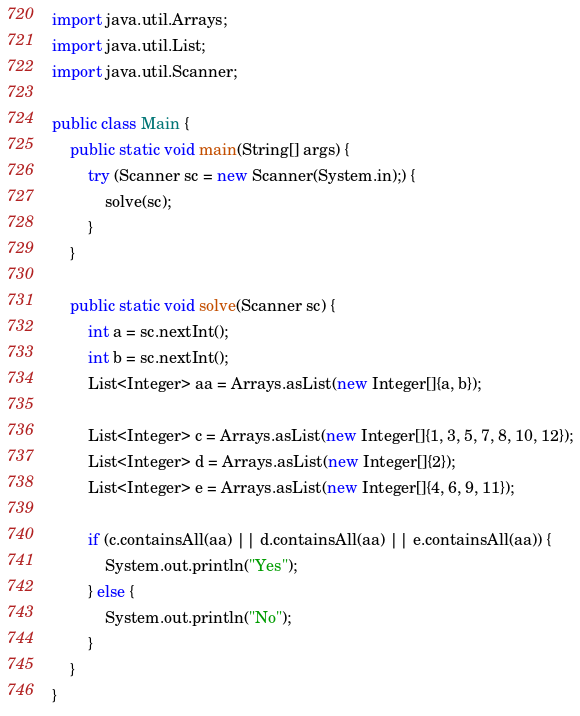<code> <loc_0><loc_0><loc_500><loc_500><_Java_>import java.util.Arrays;
import java.util.List;
import java.util.Scanner;

public class Main {
    public static void main(String[] args) {
        try (Scanner sc = new Scanner(System.in);) {
            solve(sc);
        }
    }

    public static void solve(Scanner sc) {
        int a = sc.nextInt();
        int b = sc.nextInt();
        List<Integer> aa = Arrays.asList(new Integer[]{a, b});

        List<Integer> c = Arrays.asList(new Integer[]{1, 3, 5, 7, 8, 10, 12});
        List<Integer> d = Arrays.asList(new Integer[]{2});
        List<Integer> e = Arrays.asList(new Integer[]{4, 6, 9, 11});

        if (c.containsAll(aa) || d.containsAll(aa) || e.containsAll(aa)) {
            System.out.println("Yes");
        } else {
            System.out.println("No");
        }
    }
}</code> 